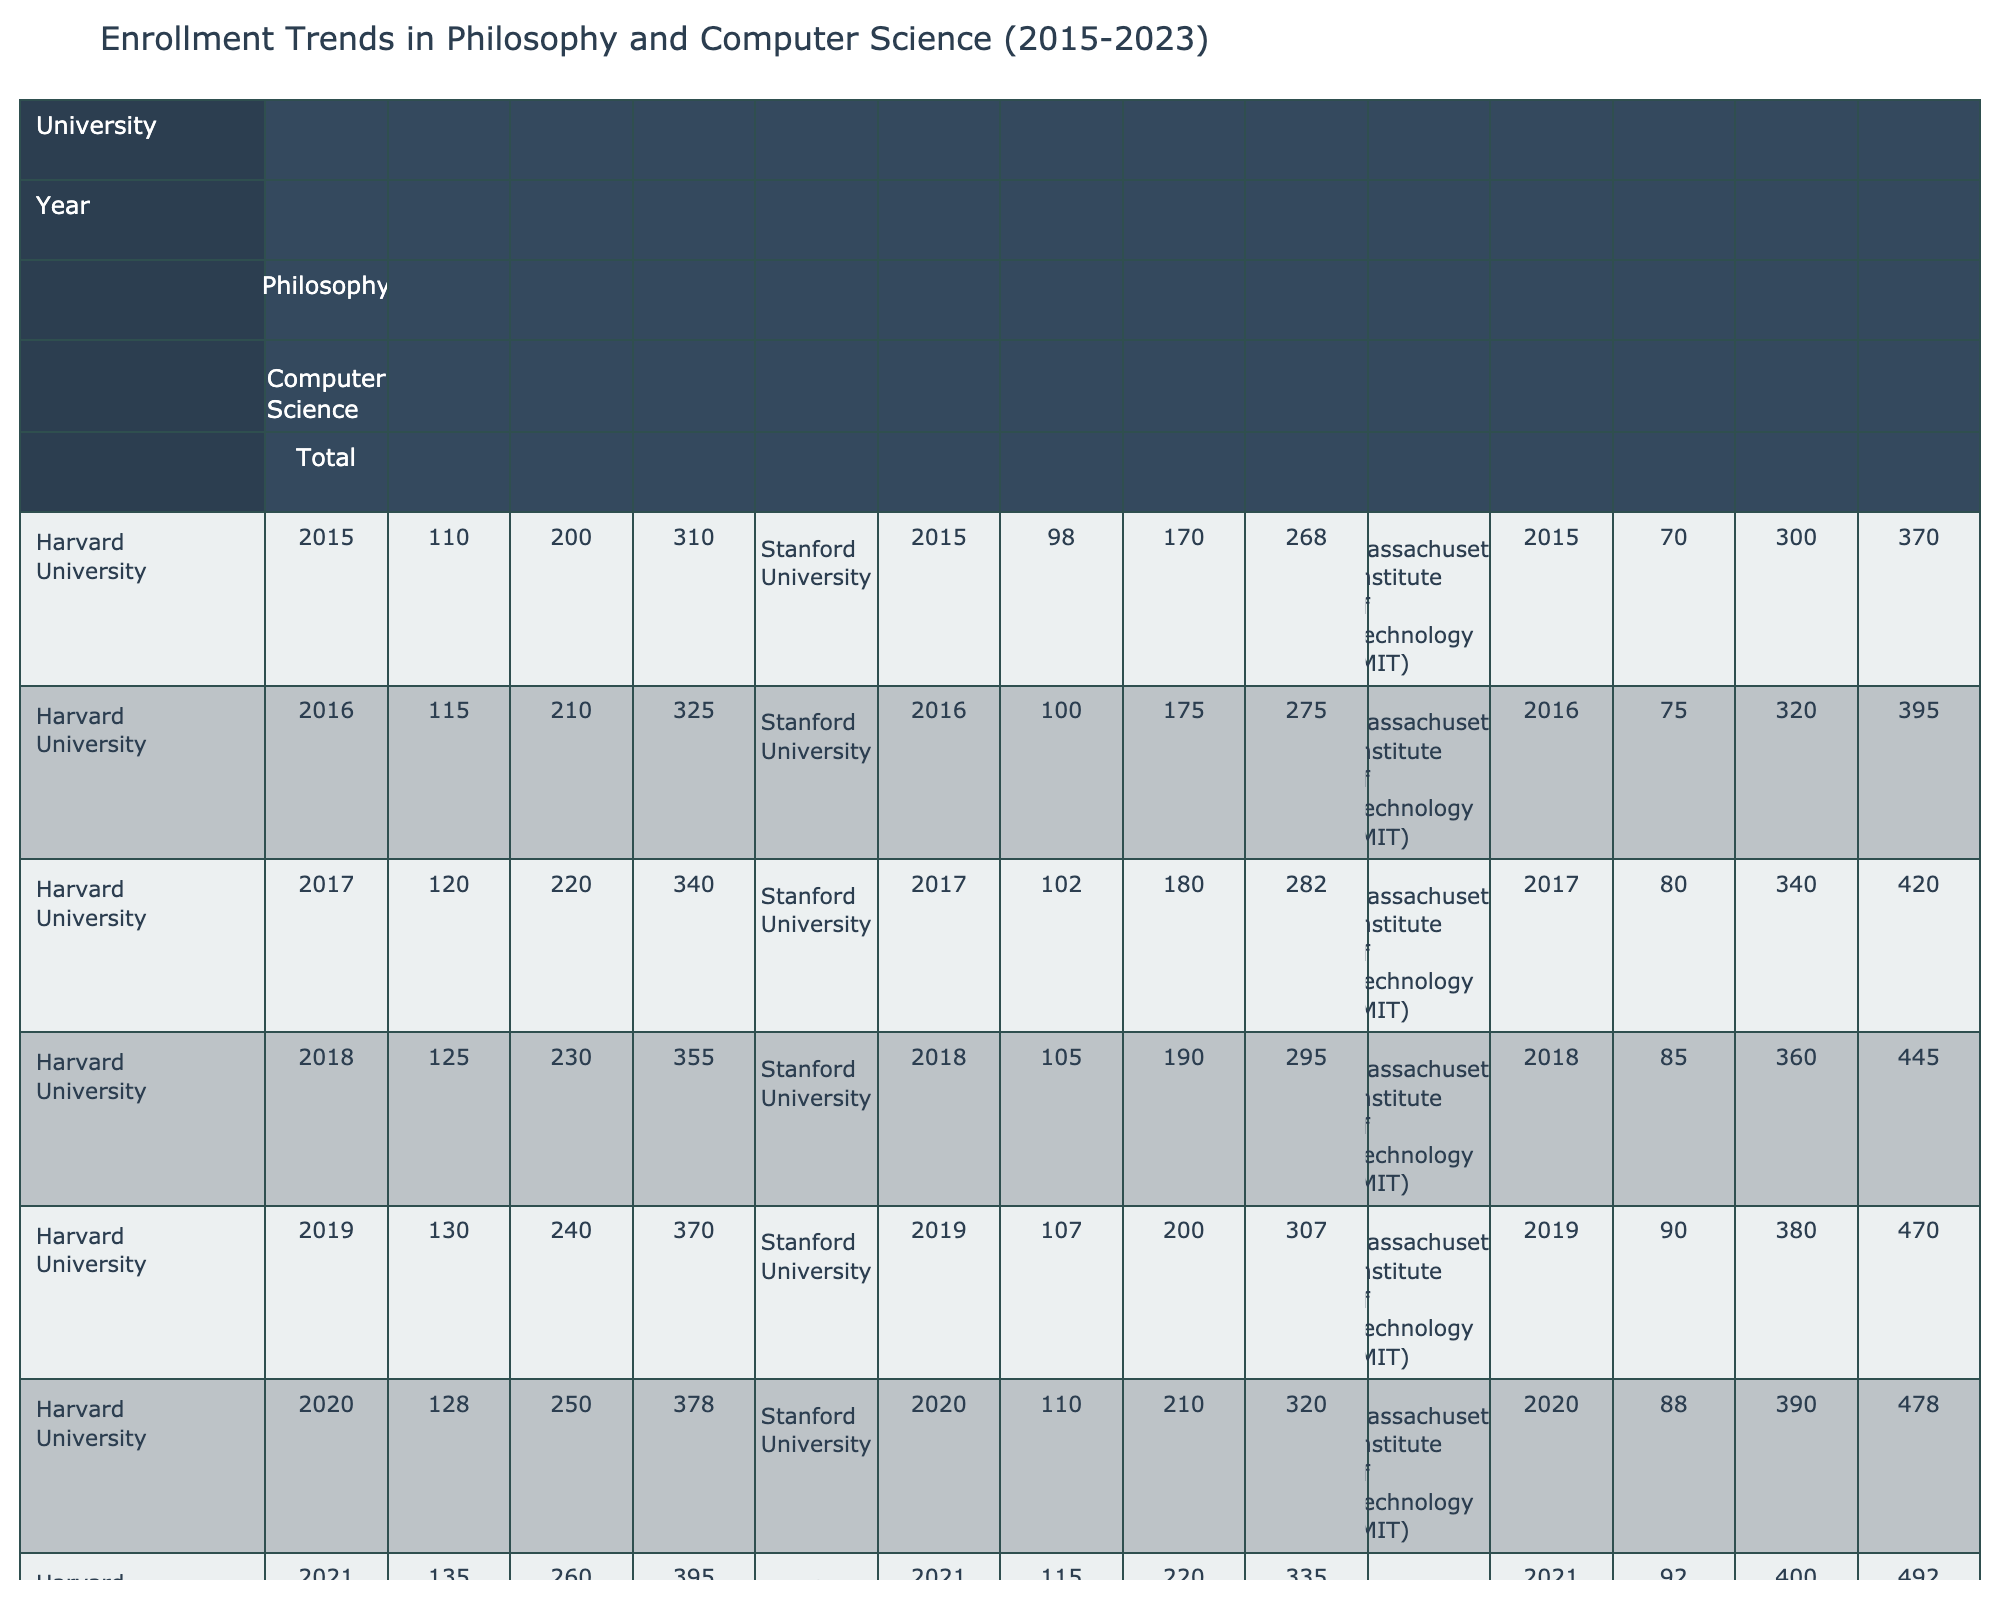What was the total enrollment in Computer Science at Harvard University in 2019? The table shows that the Computer Science enrollment at Harvard University in 2019 was 240.
Answer: 240 Which university had the highest Philosophy enrollment in 2022? According to the table, Harvard University had a Philosophy enrollment of 140 in 2022, which is higher than the other universities listed.
Answer: Harvard University What is the average Philosophy enrollment at Stanford University from 2015 to 2023? To find the average, we add the Philosophy enrollments: (98 + 100 + 102 + 105 + 107 + 110 + 115 + 120 + 125) = 1,012, then divide by the number of years, 9: 1,012 / 9 ≈ 112.44
Answer: Approximately 112.44 Did the Philosophy enrollment at the Massachusetts Institute of Technology increase every year from 2015 to 2023? Reviewing the data from the table for MIT, we see a steady increase from 70 in 2015 to 100 in 2023, indicating consistent growth.
Answer: Yes What was the difference in total enrollment between Harvard University and the Massachusetts Institute of Technology in 2021? From the table, Harvard's total enrollment in 2021 was 395, while MIT's was 492. The difference is calculated by subtracting: 492 - 395 = 97.
Answer: 97 What was the trend in Computer Science enrollment at Stanford University from 2015 to 2023? By examining the enrollment numbers, we see a consistent increase from 170 in 2015 to 240 in 2023, indicating a positive trend in the department.
Answer: Positive trend What is the median total enrollment across all universities for the year 2020? Collecting the total enrollments for 2020 (378 for Harvard, 320 for Stanford, and 478 for MIT) gives us: 378, 320, 478. Sorting these numbers gives 320, 378, 478; the median is the middle value: 378.
Answer: 378 Which university experienced the smallest increase in Philosophy enrollment from 2020 to 2021? Checking the enrollment for Philosophy at each university from those years shows that Harvard's enrollment rose from 128 to 135 (7 increases), while other universities had larger increases; thus, Harvard had the smallest increase.
Answer: Harvard University What was the highest combined enrollment for Computer Science and Philosophy at any university in 2023? The total enrollment for 2023 can be calculated by adding Computer Science and Philosophy enrollments for each university: Harvard (145 + 280 = 425), Stanford (125 + 240 = 365), MIT (100 + 420 = 520). The highest is MIT with 520.
Answer: 520 